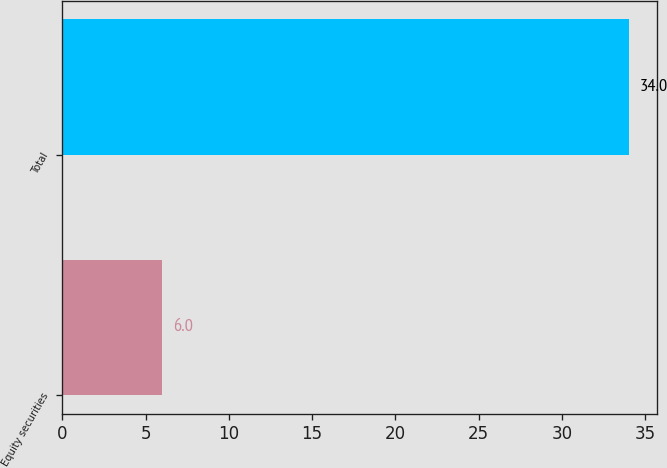Convert chart. <chart><loc_0><loc_0><loc_500><loc_500><bar_chart><fcel>Equity securities<fcel>Total<nl><fcel>6<fcel>34<nl></chart> 